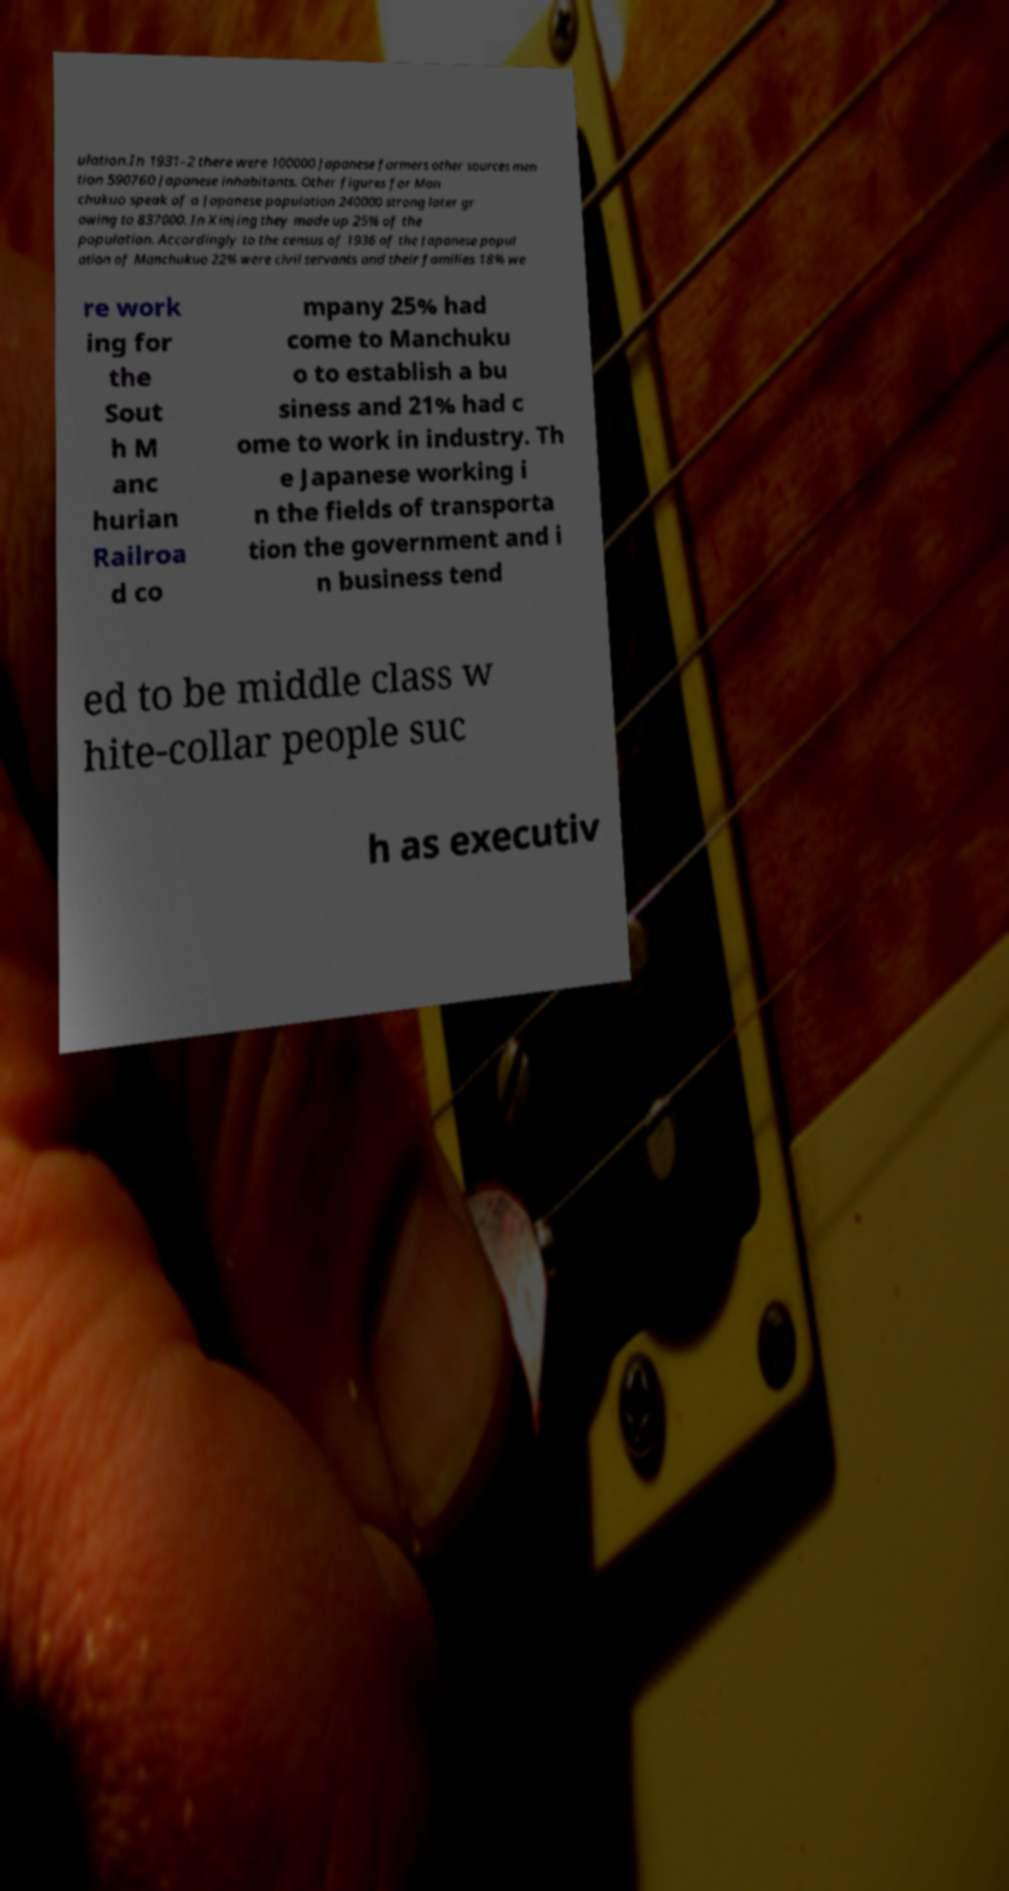Can you accurately transcribe the text from the provided image for me? ulation.In 1931–2 there were 100000 Japanese farmers other sources men tion 590760 Japanese inhabitants. Other figures for Man chukuo speak of a Japanese population 240000 strong later gr owing to 837000. In Xinjing they made up 25% of the population. Accordingly to the census of 1936 of the Japanese popul ation of Manchukuo 22% were civil servants and their families 18% we re work ing for the Sout h M anc hurian Railroa d co mpany 25% had come to Manchuku o to establish a bu siness and 21% had c ome to work in industry. Th e Japanese working i n the fields of transporta tion the government and i n business tend ed to be middle class w hite-collar people suc h as executiv 